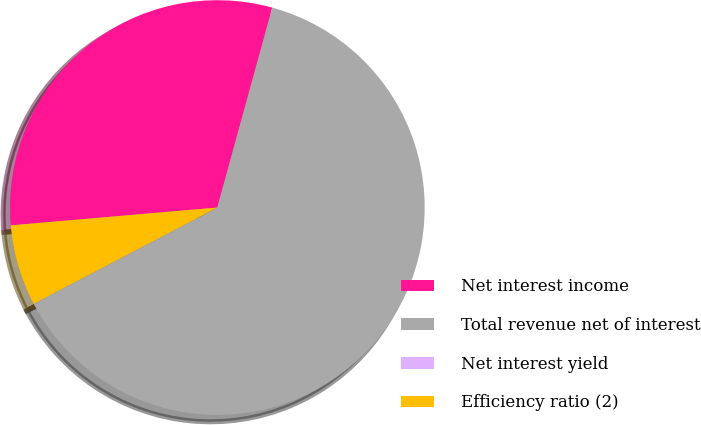<chart> <loc_0><loc_0><loc_500><loc_500><pie_chart><fcel>Net interest income<fcel>Total revenue net of interest<fcel>Net interest yield<fcel>Efficiency ratio (2)<nl><fcel>30.64%<fcel>63.04%<fcel>0.01%<fcel>6.31%<nl></chart> 